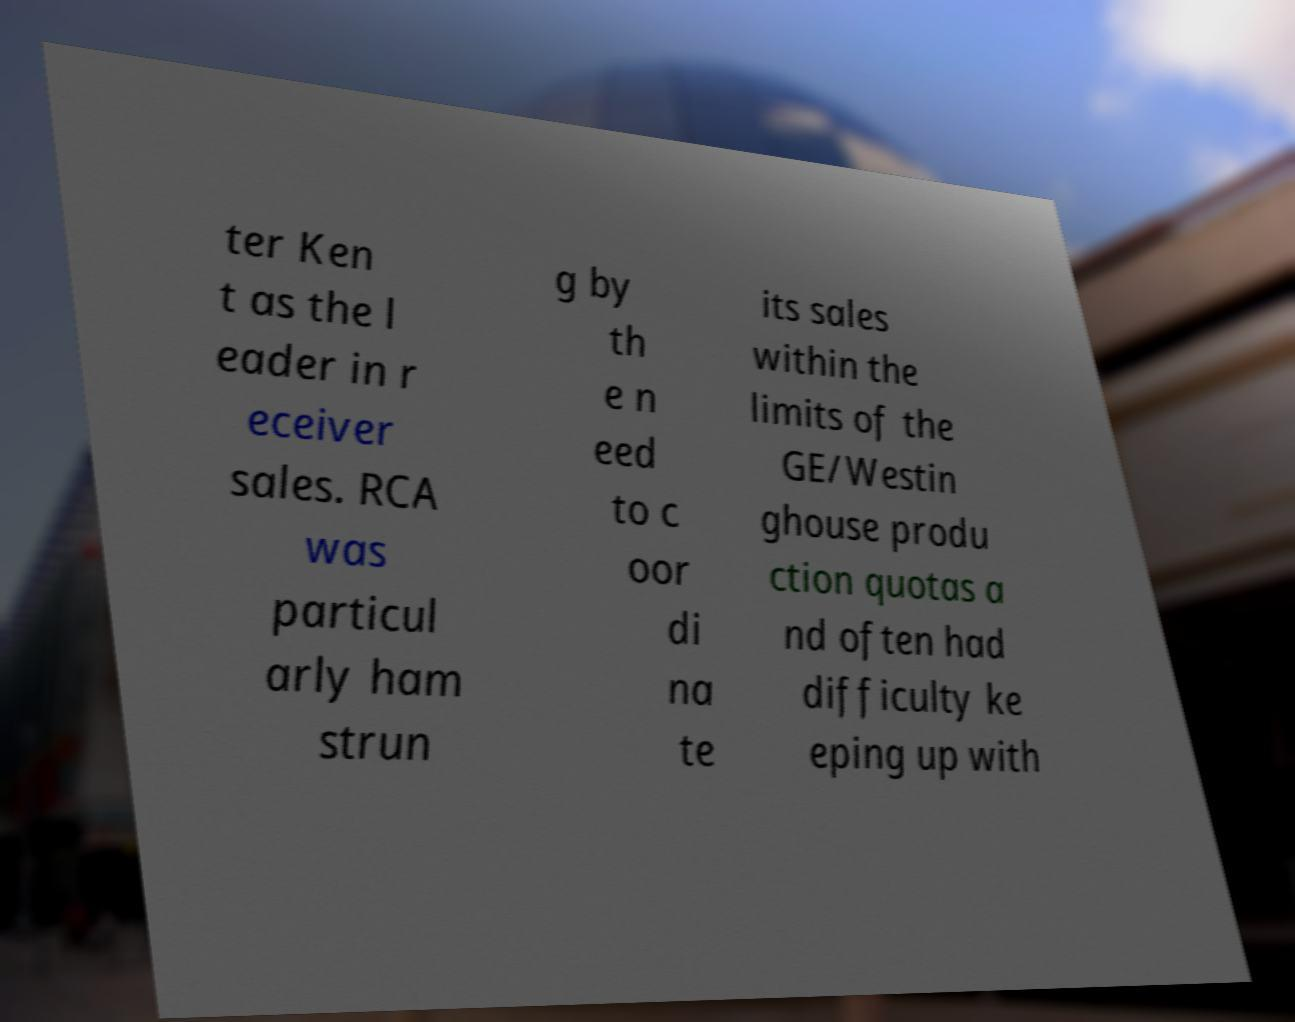Can you read and provide the text displayed in the image?This photo seems to have some interesting text. Can you extract and type it out for me? ter Ken t as the l eader in r eceiver sales. RCA was particul arly ham strun g by th e n eed to c oor di na te its sales within the limits of the GE/Westin ghouse produ ction quotas a nd often had difficulty ke eping up with 